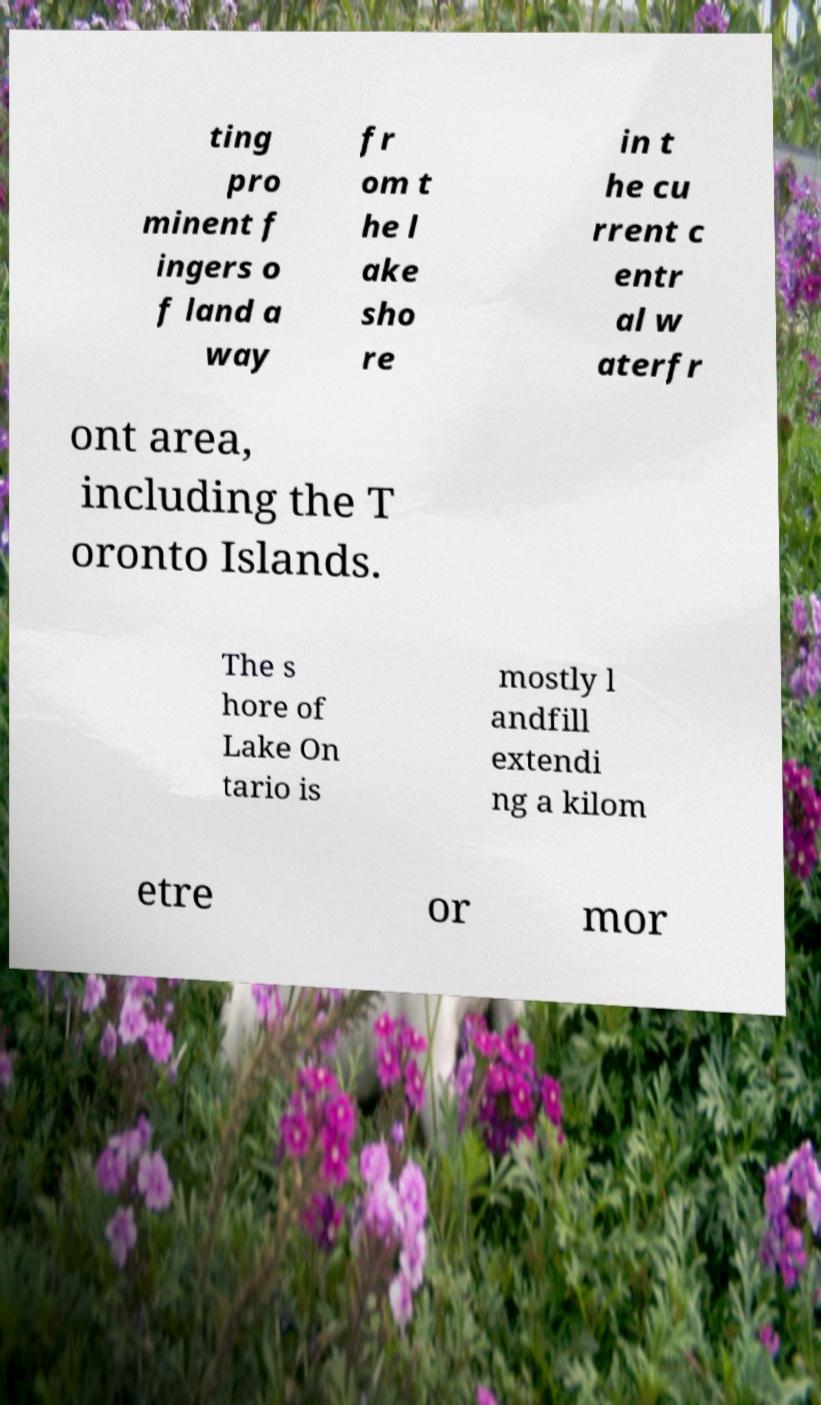Could you assist in decoding the text presented in this image and type it out clearly? ting pro minent f ingers o f land a way fr om t he l ake sho re in t he cu rrent c entr al w aterfr ont area, including the T oronto Islands. The s hore of Lake On tario is mostly l andfill extendi ng a kilom etre or mor 